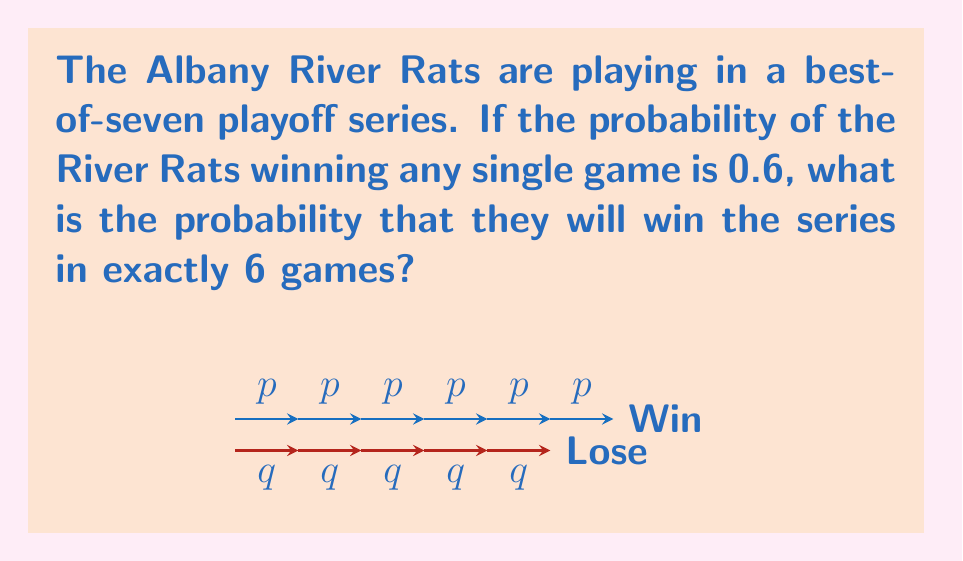Give your solution to this math problem. To solve this problem, we need to follow these steps:

1) For the River Rats to win in exactly 6 games, they need to:
   - Win 3 out of the first 5 games
   - Win the 6th game

2) The probability of winning 3 out of 5 games can be calculated using the binomial probability formula:

   $$P(\text{3 wins in 5 games}) = \binom{5}{3} p^3 q^2$$

   Where $p = 0.6$ (probability of winning a game) and $q = 1-p = 0.4$ (probability of losing a game)

3) Calculate this probability:
   $$\binom{5}{3} (0.6)^3 (0.4)^2 = 10 \cdot 0.216 \cdot 0.16 = 0.3456$$

4) The probability of winning the 6th game is simply $p = 0.6$

5) The probability of both events occurring is the product of their individual probabilities:

   $$P(\text{win in 6 games}) = P(\text{3 wins in 5 games}) \cdot P(\text{win 6th game})$$
   $$= 0.3456 \cdot 0.6 = 0.20736$$

Therefore, the probability that the Albany River Rats will win the series in exactly 6 games is 0.20736 or about 20.74%.
Answer: $0.20736$ 